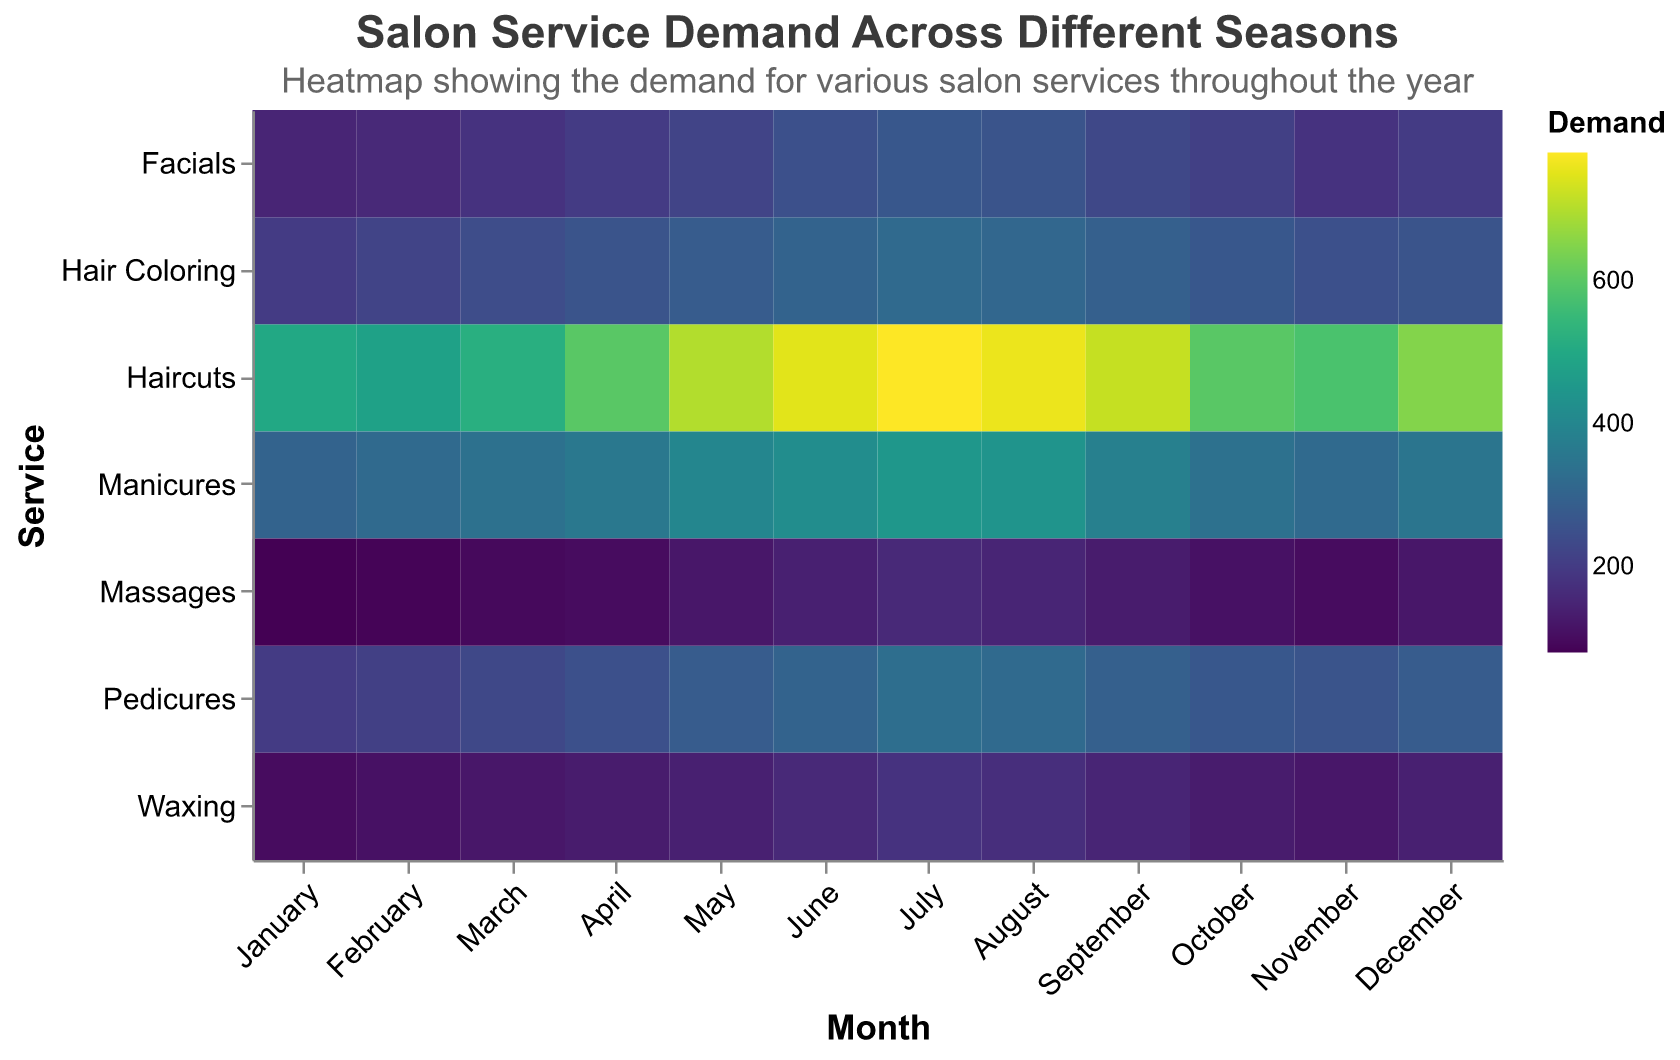What's the most demanded service in July? To find the most demanded service in July, look at the 'July' column and identify the highest value across the different services. The highest value in the July column is 780 for Haircuts.
Answer: Haircuts What's the lowest demand for Massages throughout the year? Scan through the 'Massages' row to find the smallest value. The smallest value for Massages is 80 in January.
Answer: 80 In which month are Facials most in demand? Look at the 'Facials' row and identify the month with the highest value. The highest value for Facials is 270 in July.
Answer: July Which service has the most consistent demand throughout the year? To identify the most consistent demand, examine each service's row to see which one has the least variation in values. The service with the least variation is Massages (from 80 to 160).
Answer: Massages During which seasons do Pedicures see a peak in demand? Pedicures' peak demands are seen in the summer months—June to August—with values of 300, 330, and 320, respectively. Therefore, the peak is in the summer.
Answer: Summer What’s the percentage increase in demand for Haircuts from January to July? The demand in January is 500 and in July is 780. Calculate the increase: (780 - 500) / 500 * 100%. The increase is 56%.
Answer: 56% What is the average demand for Hair Coloring across all months? Sum all values in the 'Hair Coloring' row and divide by the number of months (12): (200+220+240+260+280+300+320+310+290+270+250+260)/12 = 266.67
Answer: 266.67 Compare the demand for Waxing in May and August. Which is higher? Look at the values for Waxing in May (140) and August (170). August has a higher demand.
Answer: August Which month has the highest overall salon service demand? Sum the values for each month and compare. July has the highest overall demand with a total of 2490.
Answer: July 